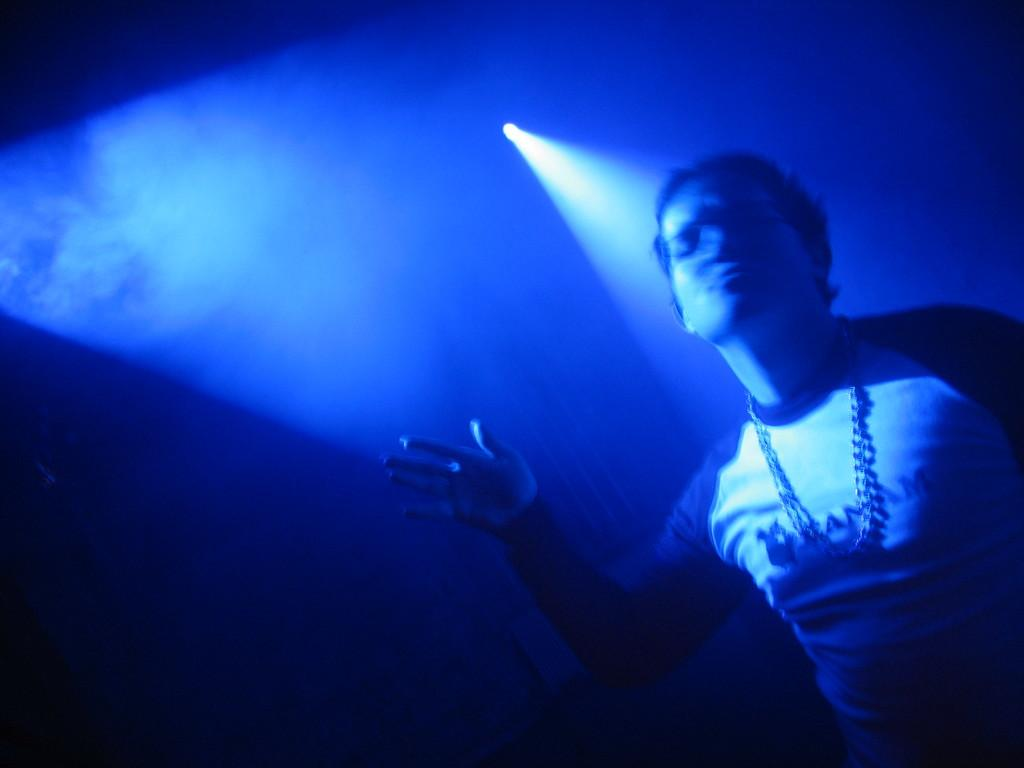Who or what is the main subject in the image? There is a person in the image. What can be observed about the background of the image? The background of the image is dark, with light and smoke visible. What type of tooth is being used to create the smoke in the image? There is no tooth present in the image, and the smoke is not being created by a tooth. 